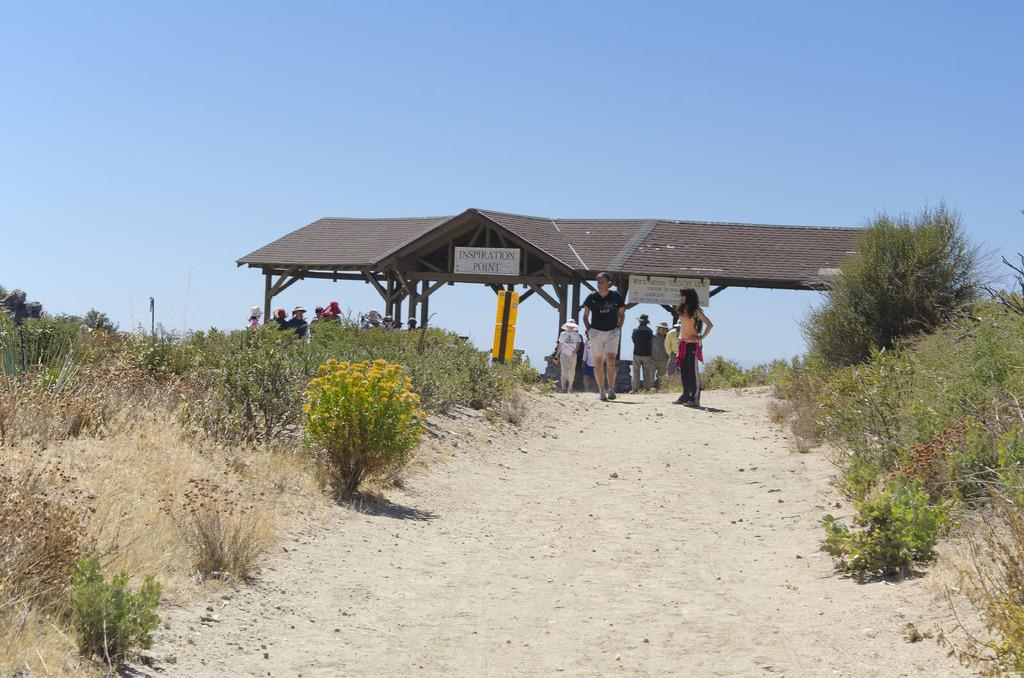What type of structure is present in the image? There is a shed in the image. Are there any people in the image? Yes, there are people in the image. What else can be seen in the image besides the shed and people? There are plants and boards with text in the image. What can be seen in the background of the image? The sky is visible in the background of the image. What type of rhythm can be heard in the song playing in the background of the image? There is no song or music playing in the background of the image, so it is not possible to determine the rhythm. 